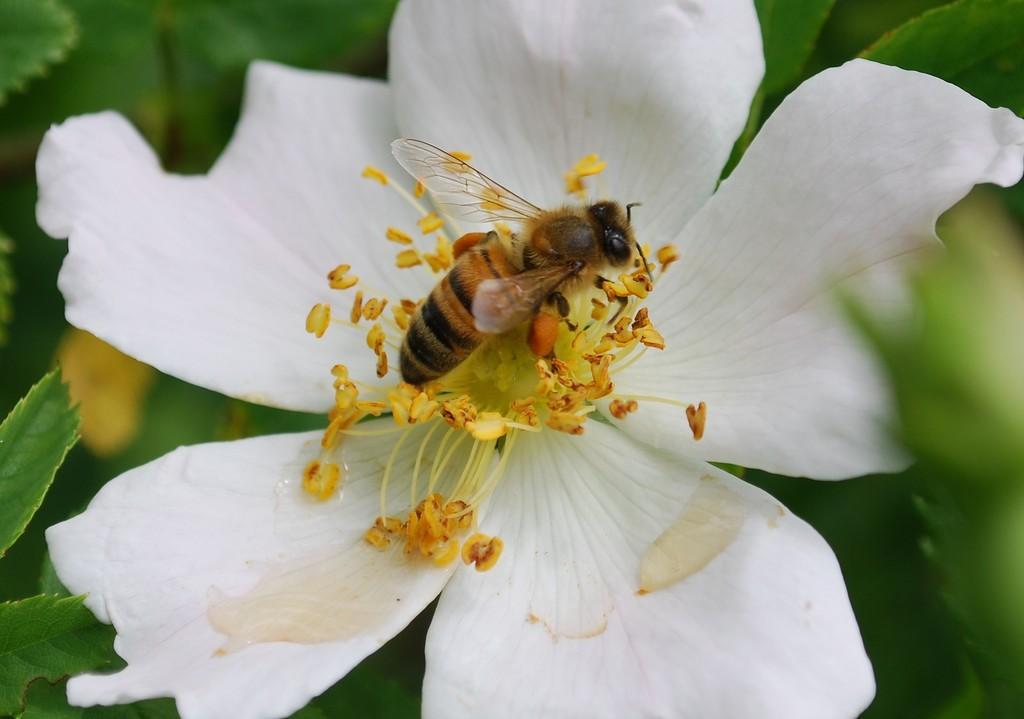Can you describe this image briefly? In the center of the image we can see a bee on the flower and there are leaves. 